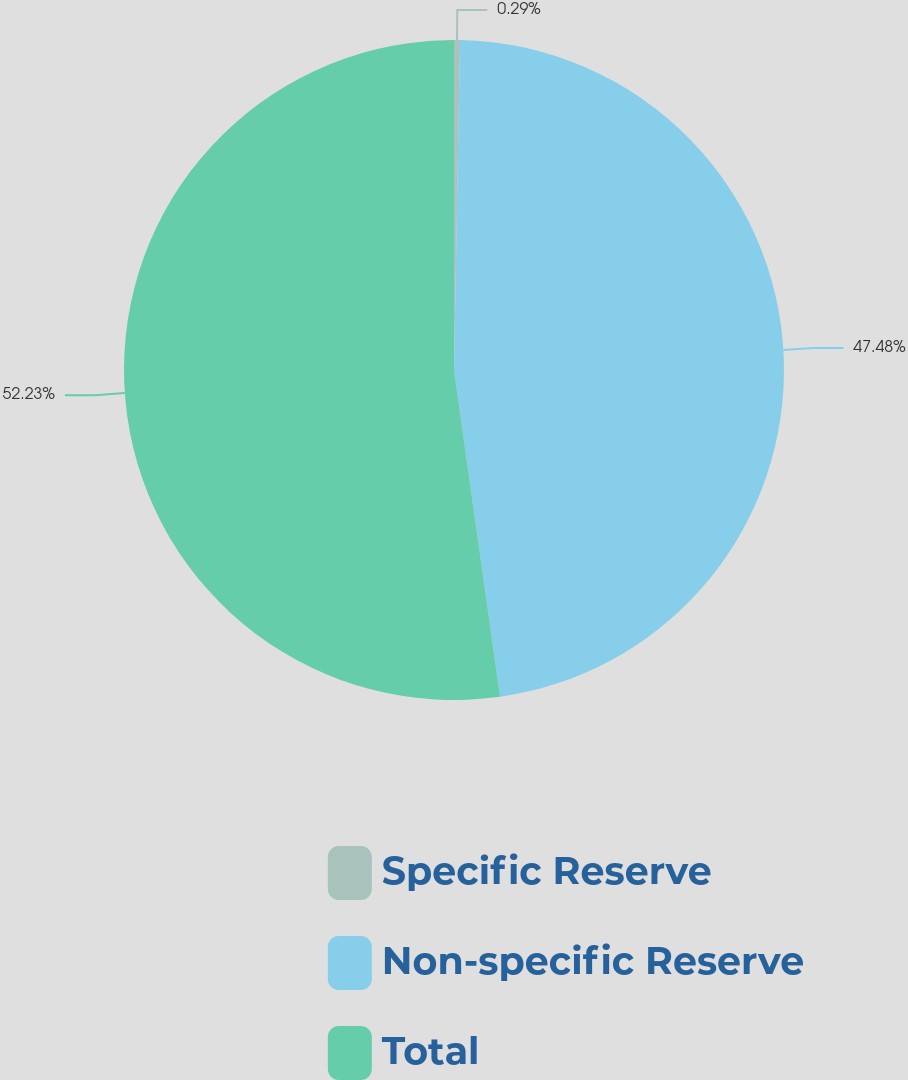<chart> <loc_0><loc_0><loc_500><loc_500><pie_chart><fcel>Specific Reserve<fcel>Non-specific Reserve<fcel>Total<nl><fcel>0.29%<fcel>47.48%<fcel>52.23%<nl></chart> 